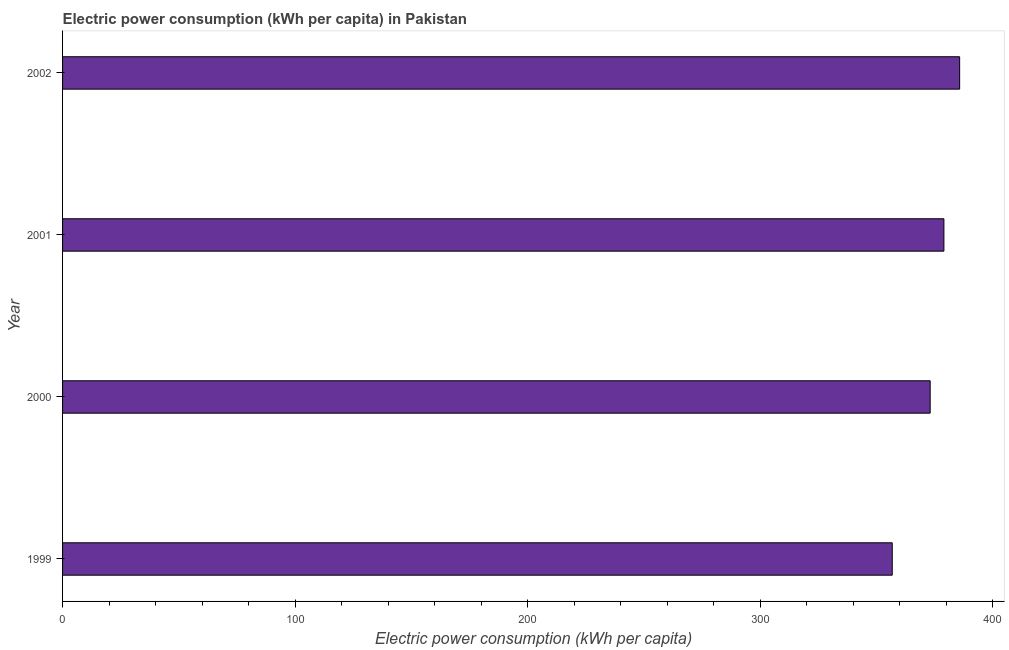What is the title of the graph?
Offer a terse response. Electric power consumption (kWh per capita) in Pakistan. What is the label or title of the X-axis?
Keep it short and to the point. Electric power consumption (kWh per capita). What is the label or title of the Y-axis?
Your response must be concise. Year. What is the electric power consumption in 2000?
Provide a succinct answer. 373.13. Across all years, what is the maximum electric power consumption?
Offer a very short reply. 385.81. Across all years, what is the minimum electric power consumption?
Ensure brevity in your answer.  356.82. In which year was the electric power consumption minimum?
Provide a short and direct response. 1999. What is the sum of the electric power consumption?
Offer a terse response. 1494.8. What is the difference between the electric power consumption in 1999 and 2000?
Your answer should be compact. -16.32. What is the average electric power consumption per year?
Provide a short and direct response. 373.7. What is the median electric power consumption?
Offer a terse response. 376.09. Is the difference between the electric power consumption in 1999 and 2002 greater than the difference between any two years?
Offer a very short reply. Yes. What is the difference between the highest and the second highest electric power consumption?
Provide a short and direct response. 6.76. Is the sum of the electric power consumption in 2001 and 2002 greater than the maximum electric power consumption across all years?
Give a very brief answer. Yes. What is the difference between the highest and the lowest electric power consumption?
Provide a short and direct response. 28.99. In how many years, is the electric power consumption greater than the average electric power consumption taken over all years?
Your answer should be compact. 2. How many years are there in the graph?
Your response must be concise. 4. What is the Electric power consumption (kWh per capita) in 1999?
Make the answer very short. 356.82. What is the Electric power consumption (kWh per capita) of 2000?
Offer a very short reply. 373.13. What is the Electric power consumption (kWh per capita) in 2001?
Make the answer very short. 379.04. What is the Electric power consumption (kWh per capita) of 2002?
Your response must be concise. 385.81. What is the difference between the Electric power consumption (kWh per capita) in 1999 and 2000?
Provide a succinct answer. -16.32. What is the difference between the Electric power consumption (kWh per capita) in 1999 and 2001?
Provide a succinct answer. -22.22. What is the difference between the Electric power consumption (kWh per capita) in 1999 and 2002?
Ensure brevity in your answer.  -28.99. What is the difference between the Electric power consumption (kWh per capita) in 2000 and 2001?
Your answer should be very brief. -5.91. What is the difference between the Electric power consumption (kWh per capita) in 2000 and 2002?
Your answer should be very brief. -12.67. What is the difference between the Electric power consumption (kWh per capita) in 2001 and 2002?
Your response must be concise. -6.76. What is the ratio of the Electric power consumption (kWh per capita) in 1999 to that in 2000?
Make the answer very short. 0.96. What is the ratio of the Electric power consumption (kWh per capita) in 1999 to that in 2001?
Your response must be concise. 0.94. What is the ratio of the Electric power consumption (kWh per capita) in 1999 to that in 2002?
Keep it short and to the point. 0.93. What is the ratio of the Electric power consumption (kWh per capita) in 2000 to that in 2002?
Make the answer very short. 0.97. What is the ratio of the Electric power consumption (kWh per capita) in 2001 to that in 2002?
Your answer should be compact. 0.98. 